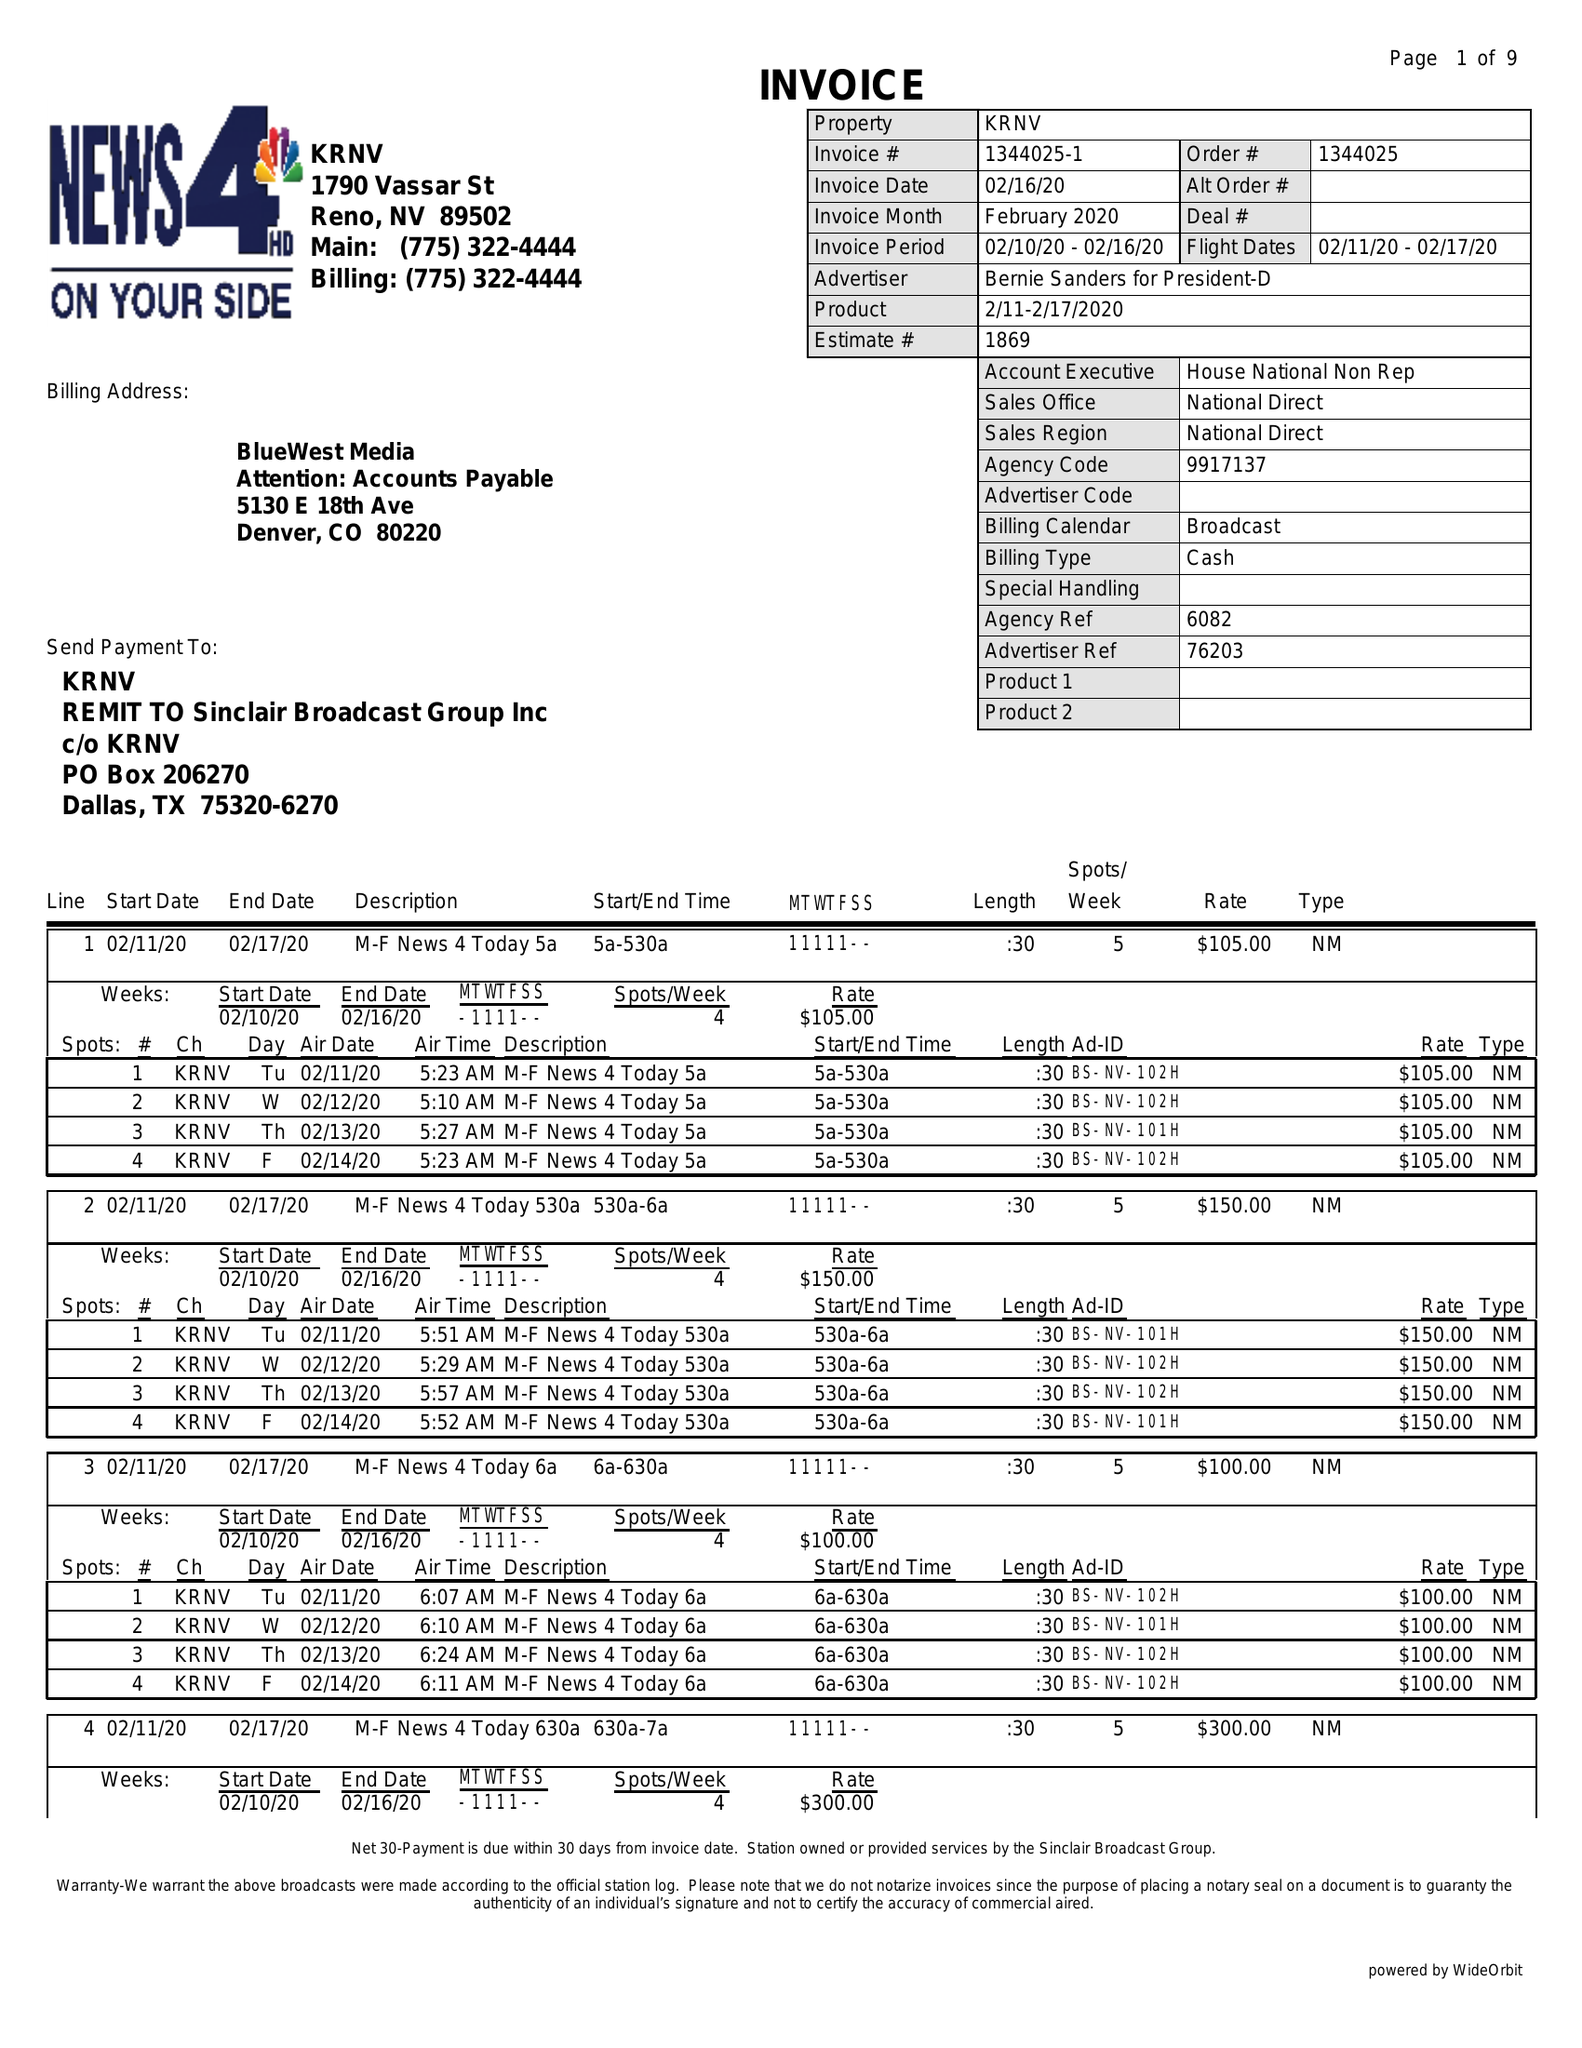What is the value for the contract_num?
Answer the question using a single word or phrase. 1344025 